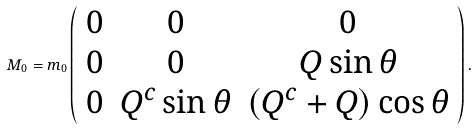Convert formula to latex. <formula><loc_0><loc_0><loc_500><loc_500>M _ { 0 } = m _ { 0 } \left ( \begin{array} { c c c } { 0 } & { 0 } & { 0 } \\ { 0 } & { 0 } & { Q \sin \theta } \\ { 0 } & { { Q ^ { c } \sin \theta } } & { { ( Q ^ { c } + Q ) \cos \theta } } \end{array} \right ) .</formula> 